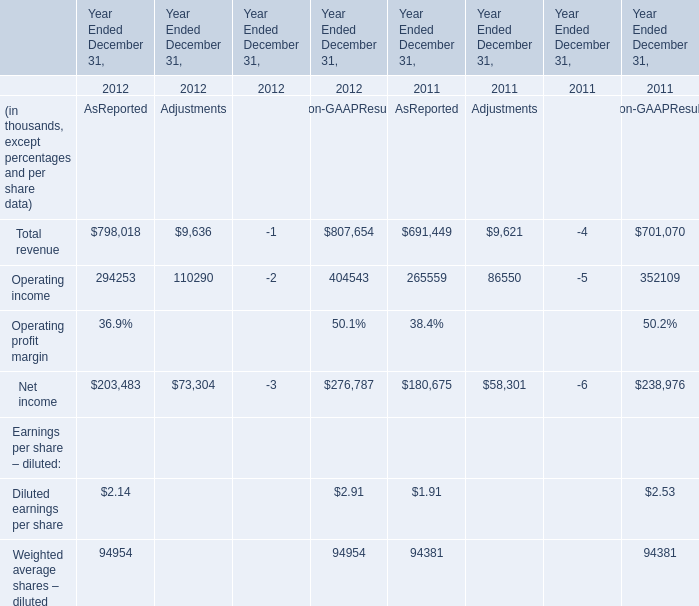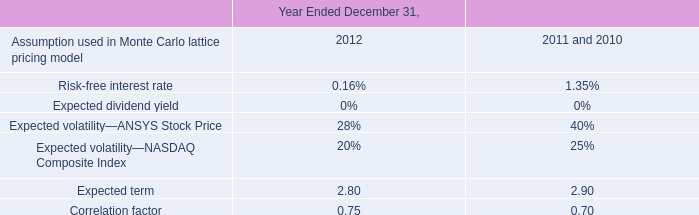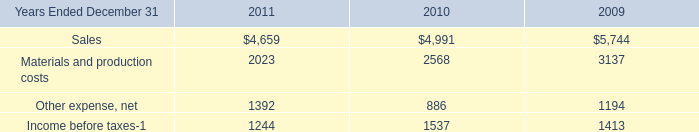What's the total value of all AsReported that are smaller than 300000 in 2012? (in thousand) 
Computations: (((294253 + 2.14) + 203483) + 94954)
Answer: 592692.14. 